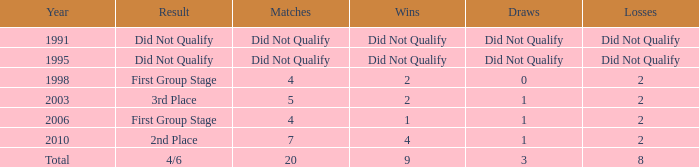What were the matches where the teams finished in the first group stage, in 1998? 4.0. 